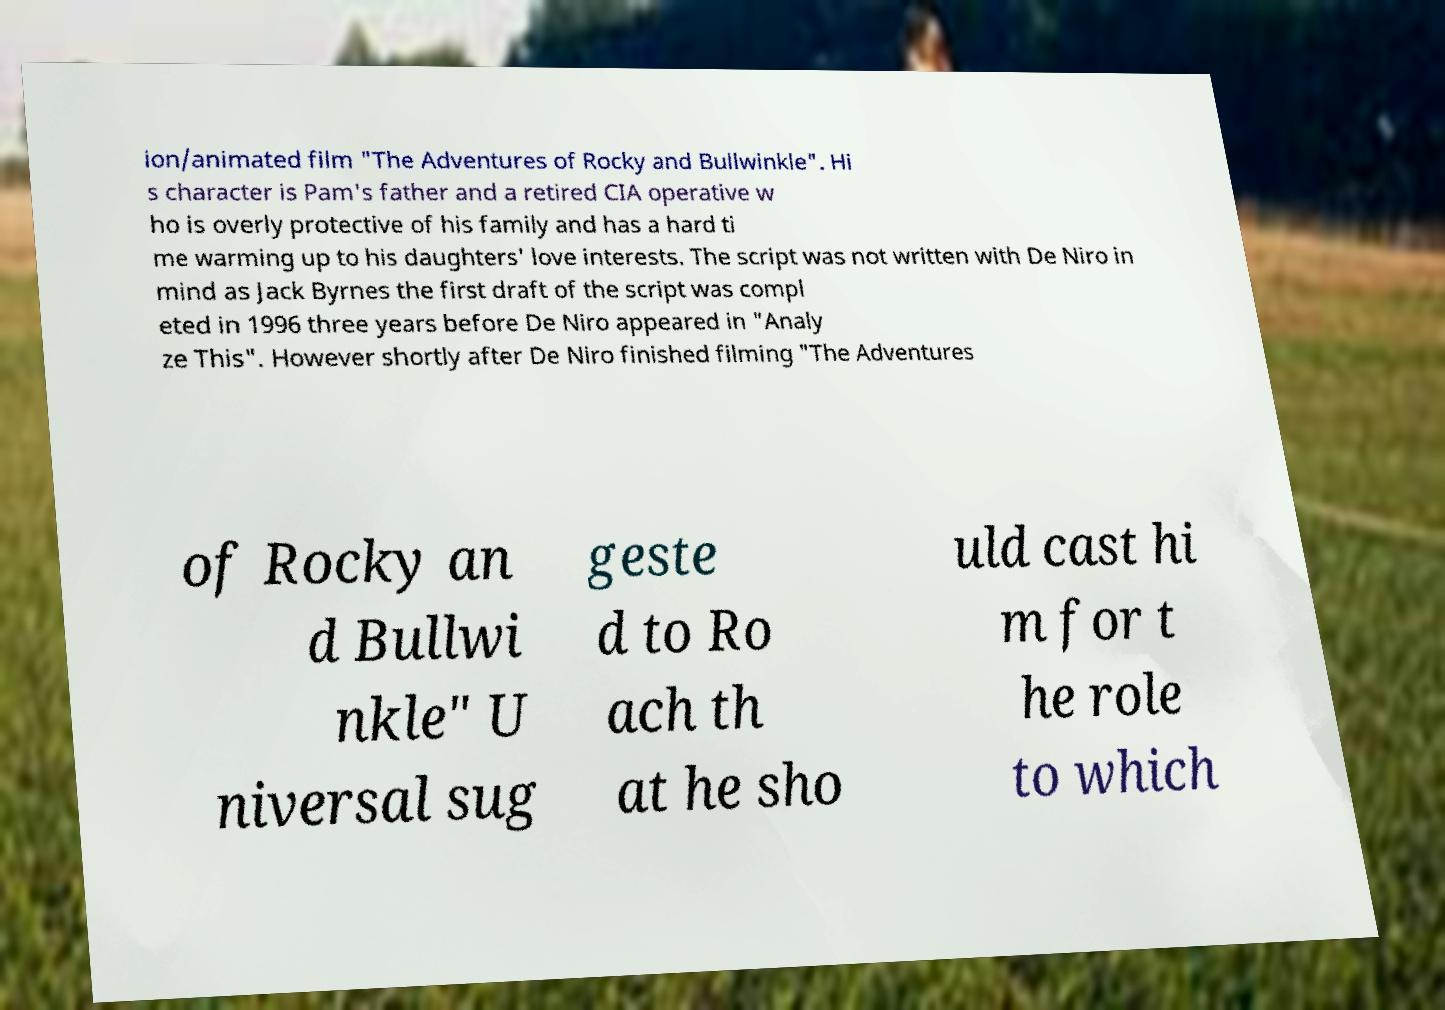Can you read and provide the text displayed in the image?This photo seems to have some interesting text. Can you extract and type it out for me? ion/animated film "The Adventures of Rocky and Bullwinkle". Hi s character is Pam's father and a retired CIA operative w ho is overly protective of his family and has a hard ti me warming up to his daughters' love interests. The script was not written with De Niro in mind as Jack Byrnes the first draft of the script was compl eted in 1996 three years before De Niro appeared in "Analy ze This". However shortly after De Niro finished filming "The Adventures of Rocky an d Bullwi nkle" U niversal sug geste d to Ro ach th at he sho uld cast hi m for t he role to which 